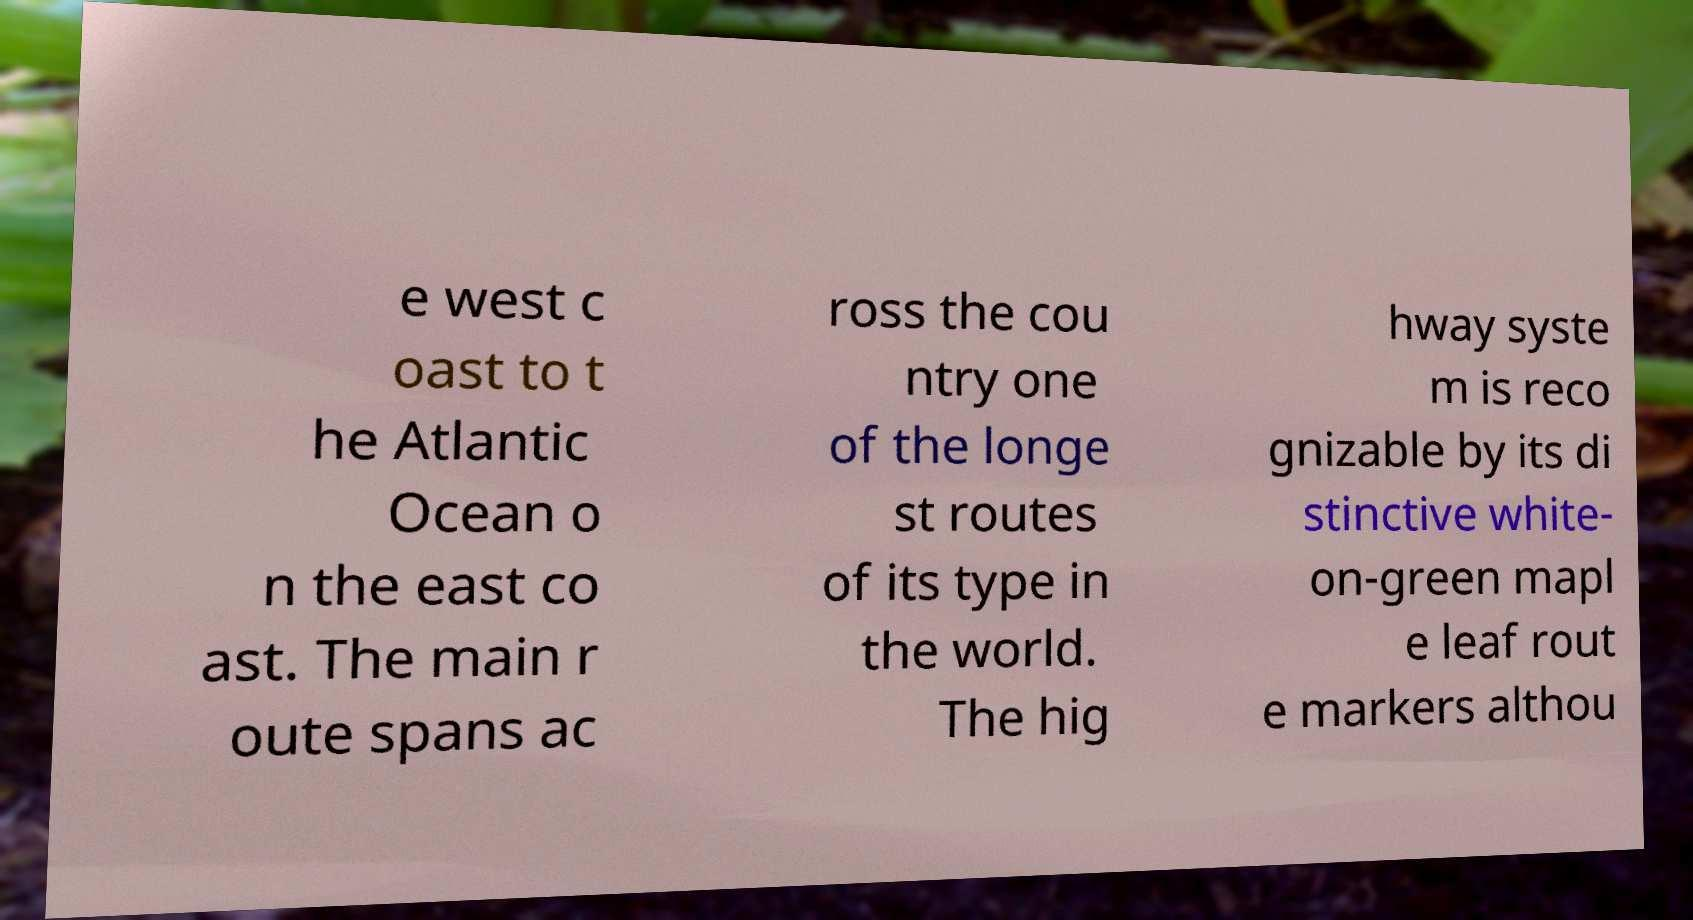Could you extract and type out the text from this image? e west c oast to t he Atlantic Ocean o n the east co ast. The main r oute spans ac ross the cou ntry one of the longe st routes of its type in the world. The hig hway syste m is reco gnizable by its di stinctive white- on-green mapl e leaf rout e markers althou 